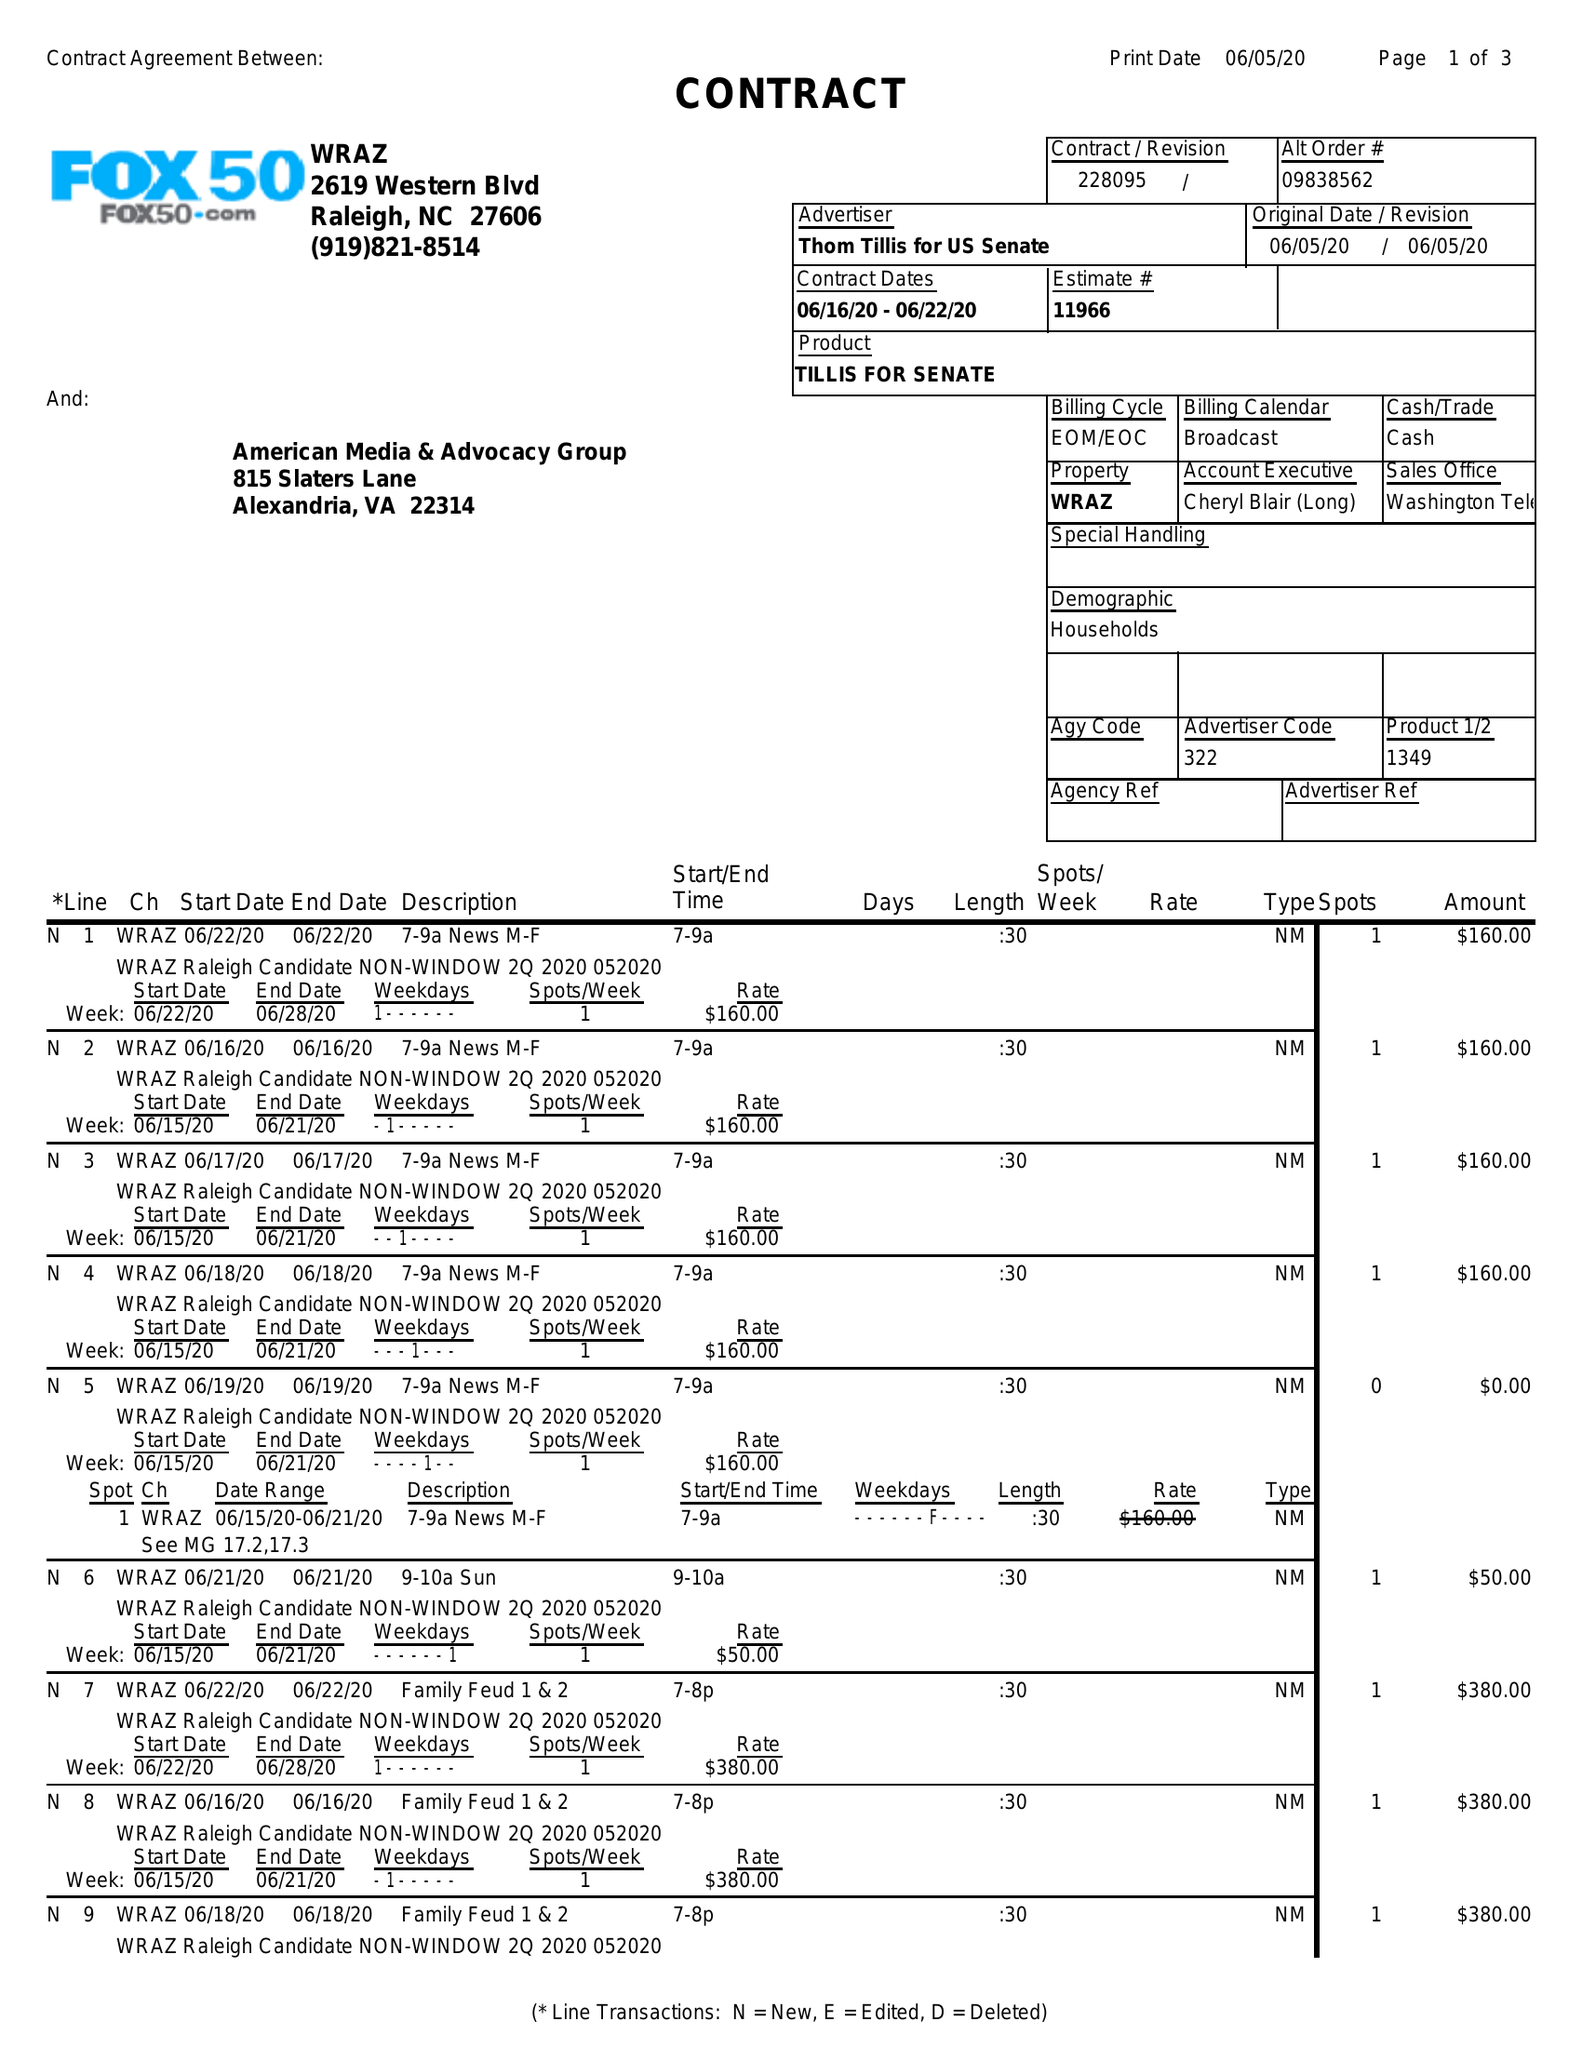What is the value for the flight_from?
Answer the question using a single word or phrase. 06/16/20 